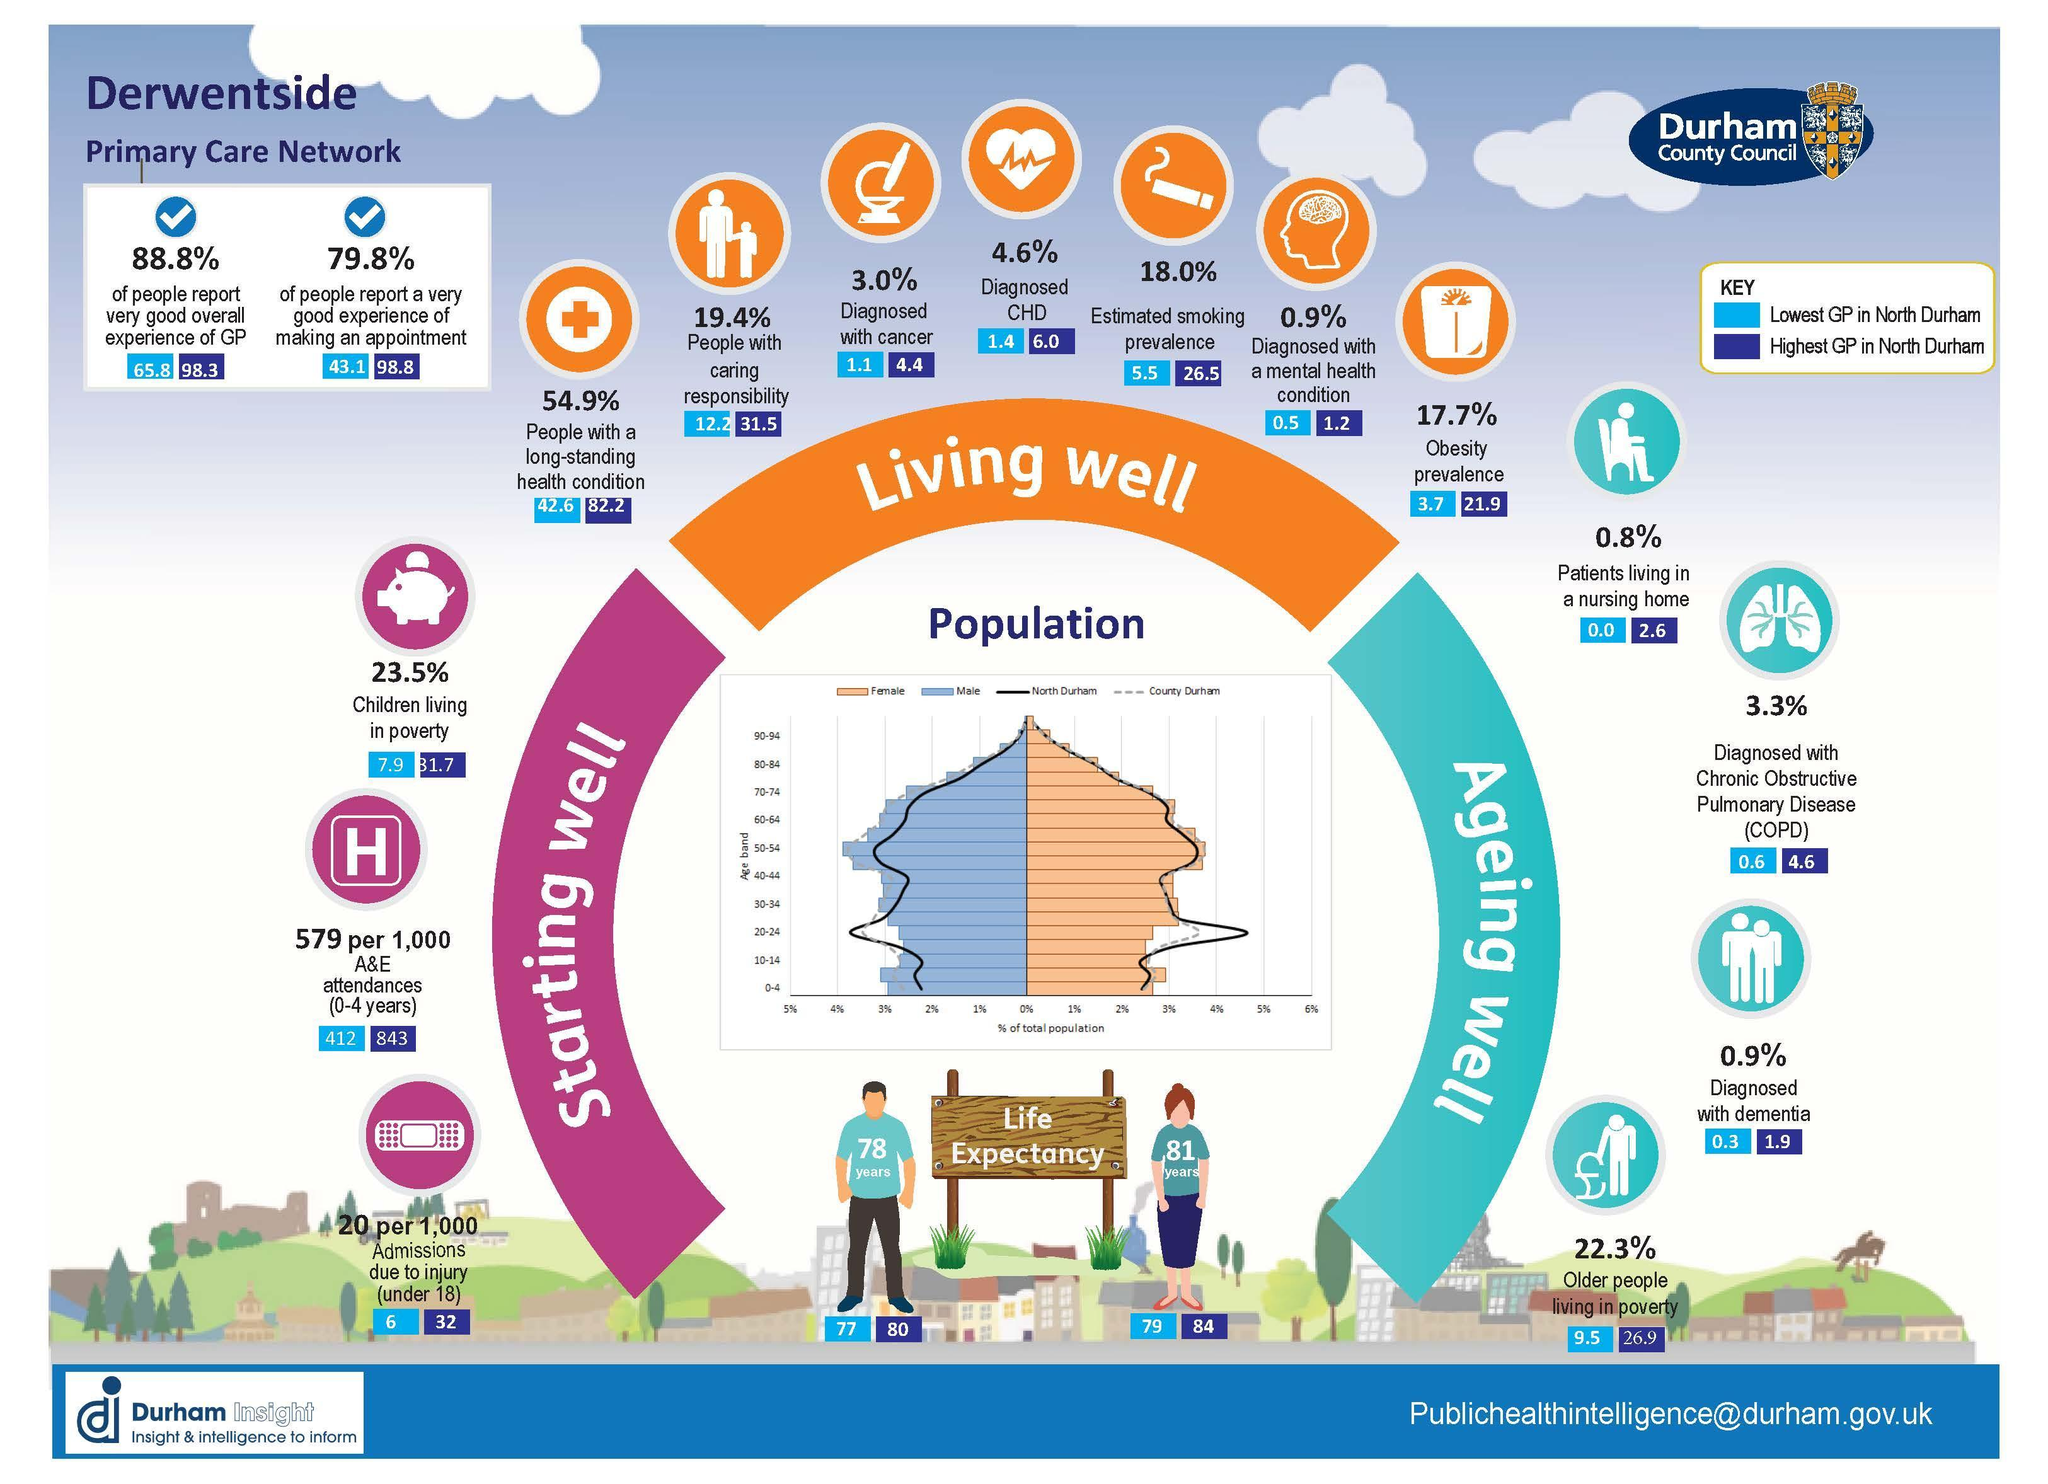What is the life expectancy of females in North Durham with the highest GP?
Answer the question with a short phrase. 84 What is the lowest GP in North Durham in which patients are living in a nursing home? 0.0 What is the life expectancy of males in North Durham with the highest GP? 80 What percentage diagnosed with a mental health condition? 0.9% What is the life expectancy of males in North Durham with the lowest GP? 77 What is the life expectancy of males? 78 years What is the life expectancy of females? 81 years Which color used to represent "Living well"-blue, orange, pink? orange What is the highest GP in North Durham in which older people living in poverty? 26.9 What is the life expectancy of females in North Durham with the lowest GP? 79 